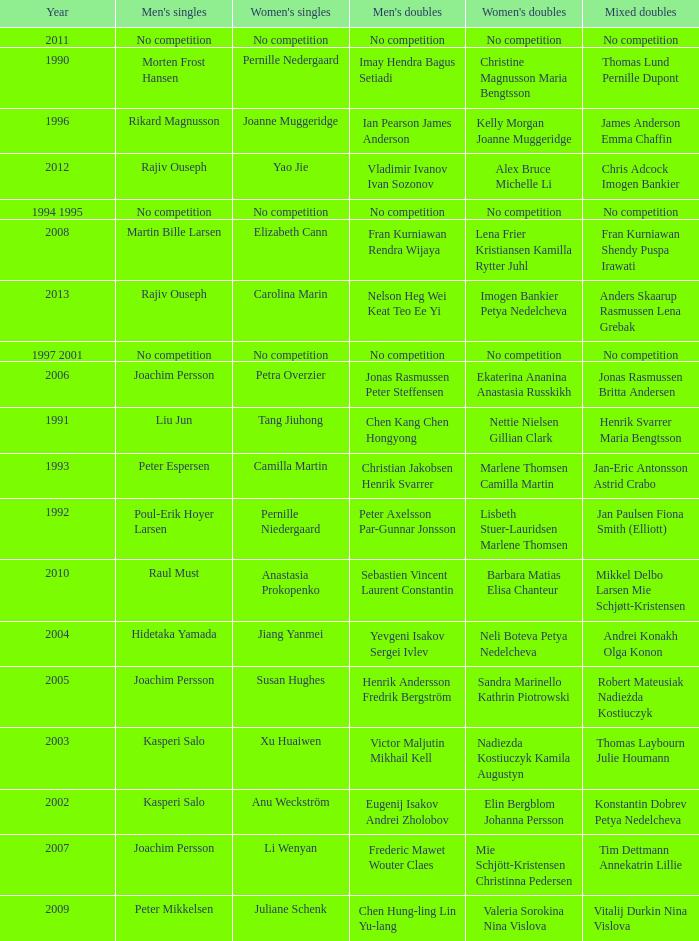Who won the Mixed Doubles in 2007? Tim Dettmann Annekatrin Lillie. 